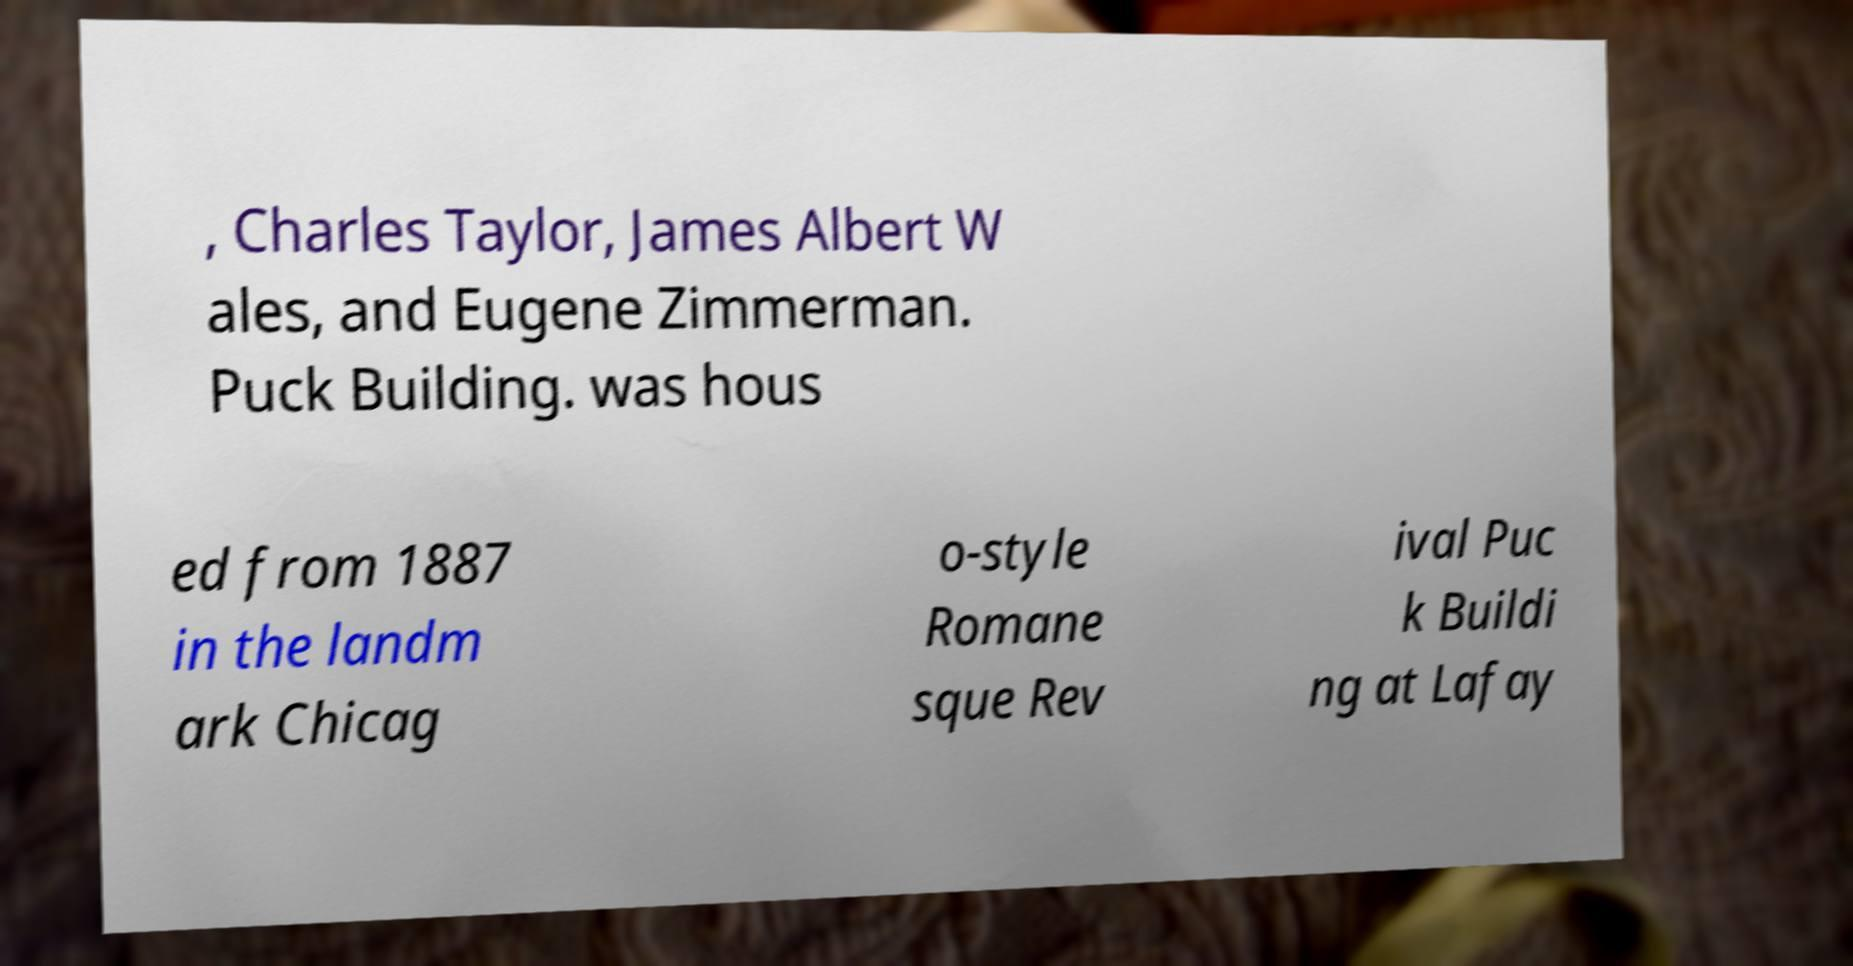I need the written content from this picture converted into text. Can you do that? , Charles Taylor, James Albert W ales, and Eugene Zimmerman. Puck Building. was hous ed from 1887 in the landm ark Chicag o-style Romane sque Rev ival Puc k Buildi ng at Lafay 